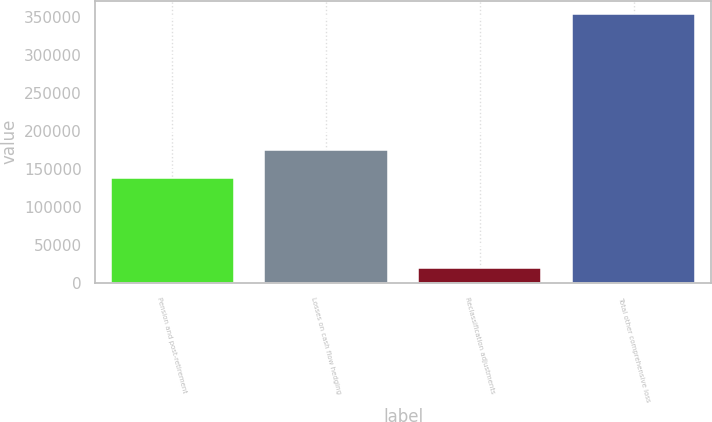<chart> <loc_0><loc_0><loc_500><loc_500><bar_chart><fcel>Pension and post-retirement<fcel>Losses on cash flow hedging<fcel>Reclassification adjustments<fcel>Total other comprehensive loss<nl><fcel>137918<fcel>175011<fcel>20282<fcel>354424<nl></chart> 